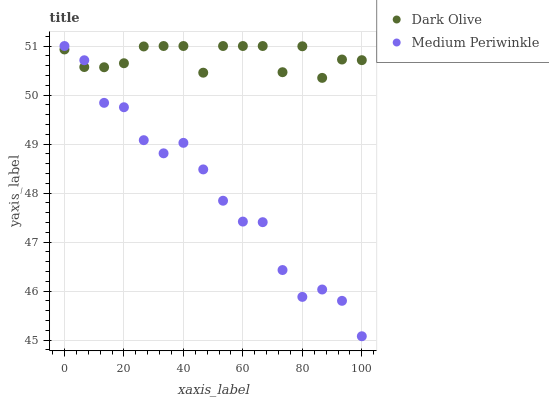Does Medium Periwinkle have the minimum area under the curve?
Answer yes or no. Yes. Does Dark Olive have the maximum area under the curve?
Answer yes or no. Yes. Does Medium Periwinkle have the maximum area under the curve?
Answer yes or no. No. Is Medium Periwinkle the smoothest?
Answer yes or no. Yes. Is Dark Olive the roughest?
Answer yes or no. Yes. Is Medium Periwinkle the roughest?
Answer yes or no. No. Does Medium Periwinkle have the lowest value?
Answer yes or no. Yes. Does Medium Periwinkle have the highest value?
Answer yes or no. Yes. Does Medium Periwinkle intersect Dark Olive?
Answer yes or no. Yes. Is Medium Periwinkle less than Dark Olive?
Answer yes or no. No. Is Medium Periwinkle greater than Dark Olive?
Answer yes or no. No. 